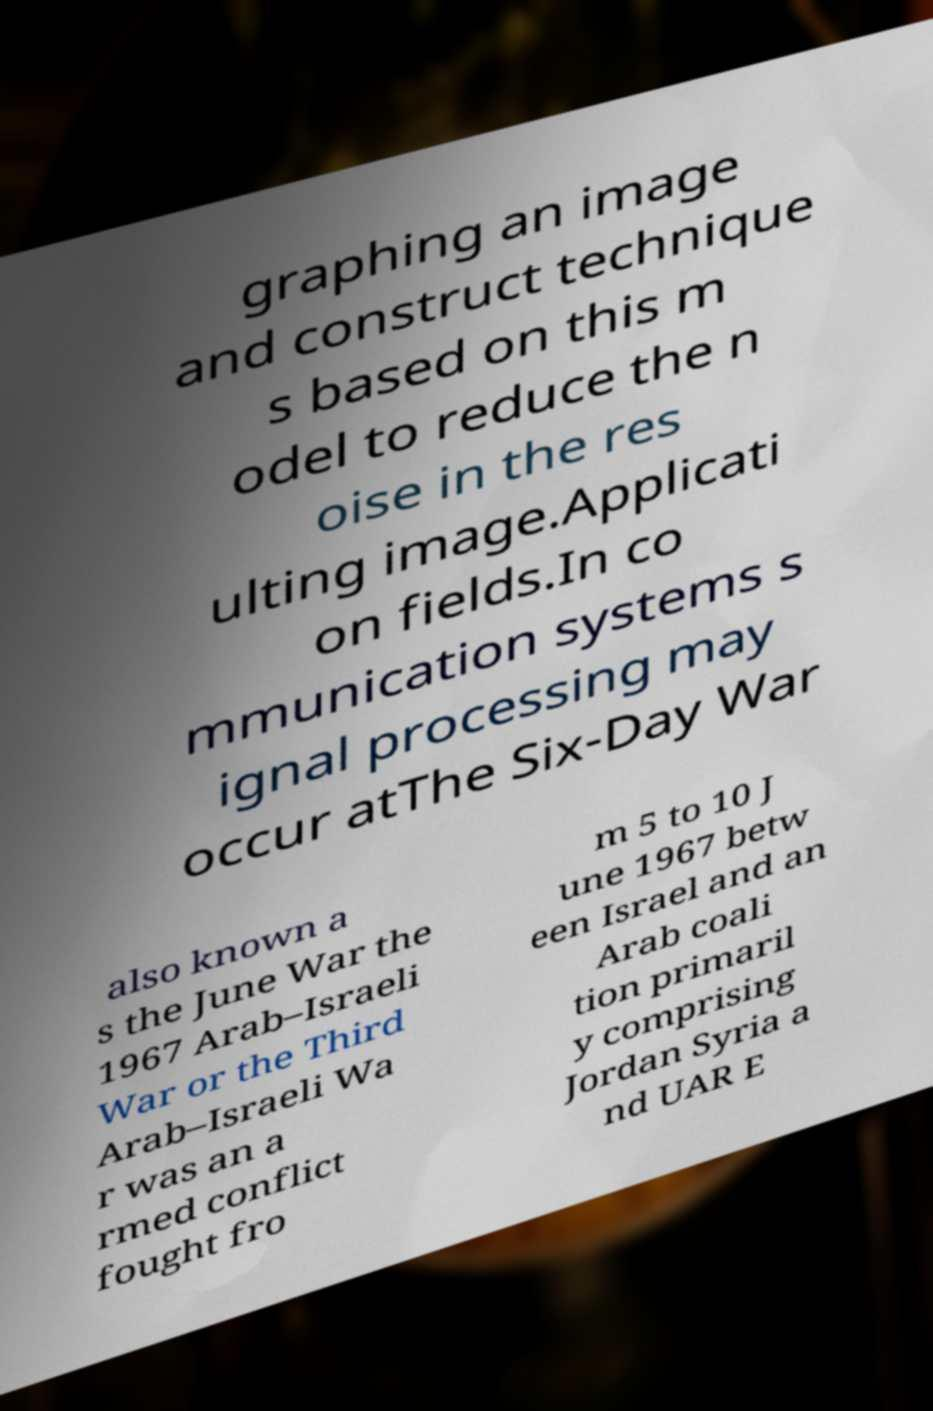There's text embedded in this image that I need extracted. Can you transcribe it verbatim? graphing an image and construct technique s based on this m odel to reduce the n oise in the res ulting image.Applicati on fields.In co mmunication systems s ignal processing may occur atThe Six-Day War also known a s the June War the 1967 Arab–Israeli War or the Third Arab–Israeli Wa r was an a rmed conflict fought fro m 5 to 10 J une 1967 betw een Israel and an Arab coali tion primaril y comprising Jordan Syria a nd UAR E 